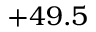Convert formula to latex. <formula><loc_0><loc_0><loc_500><loc_500>+ 4 9 . 5</formula> 